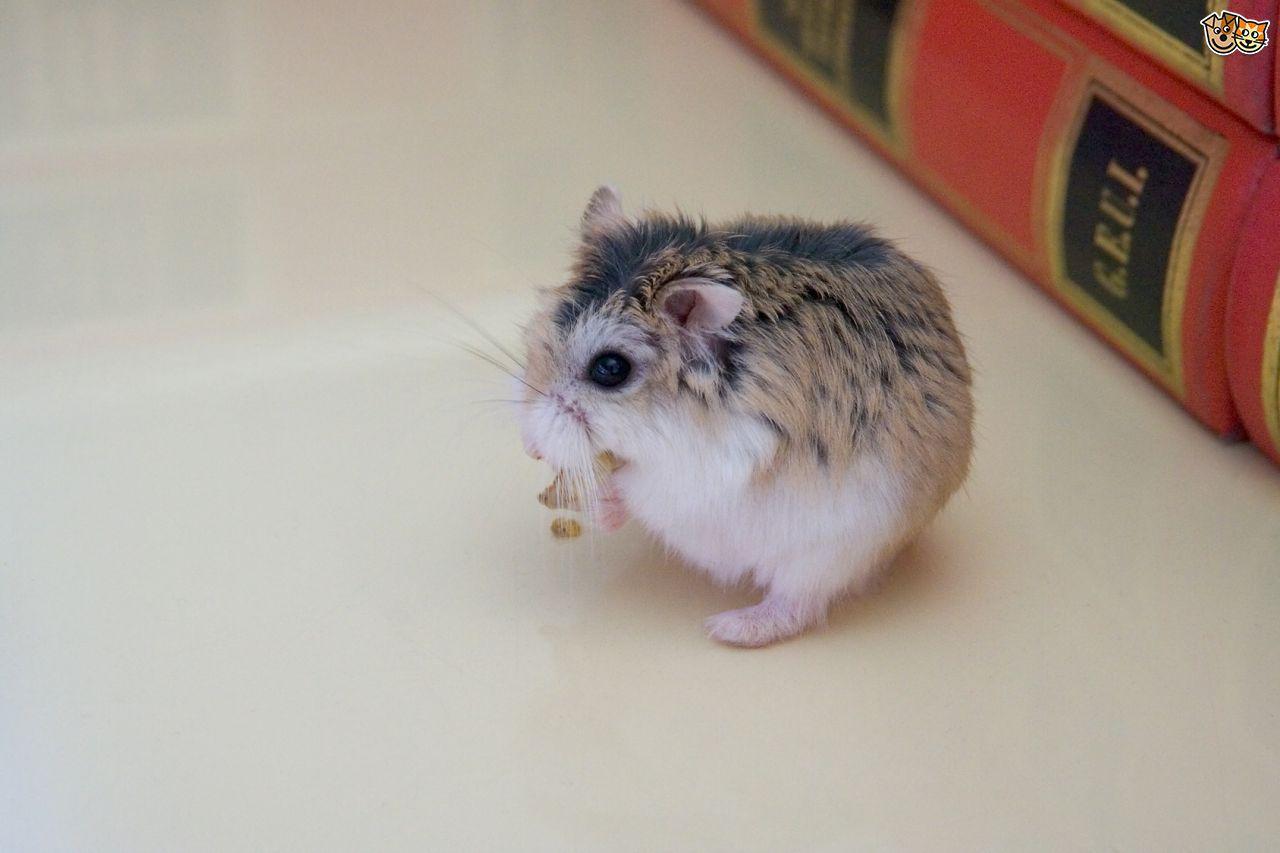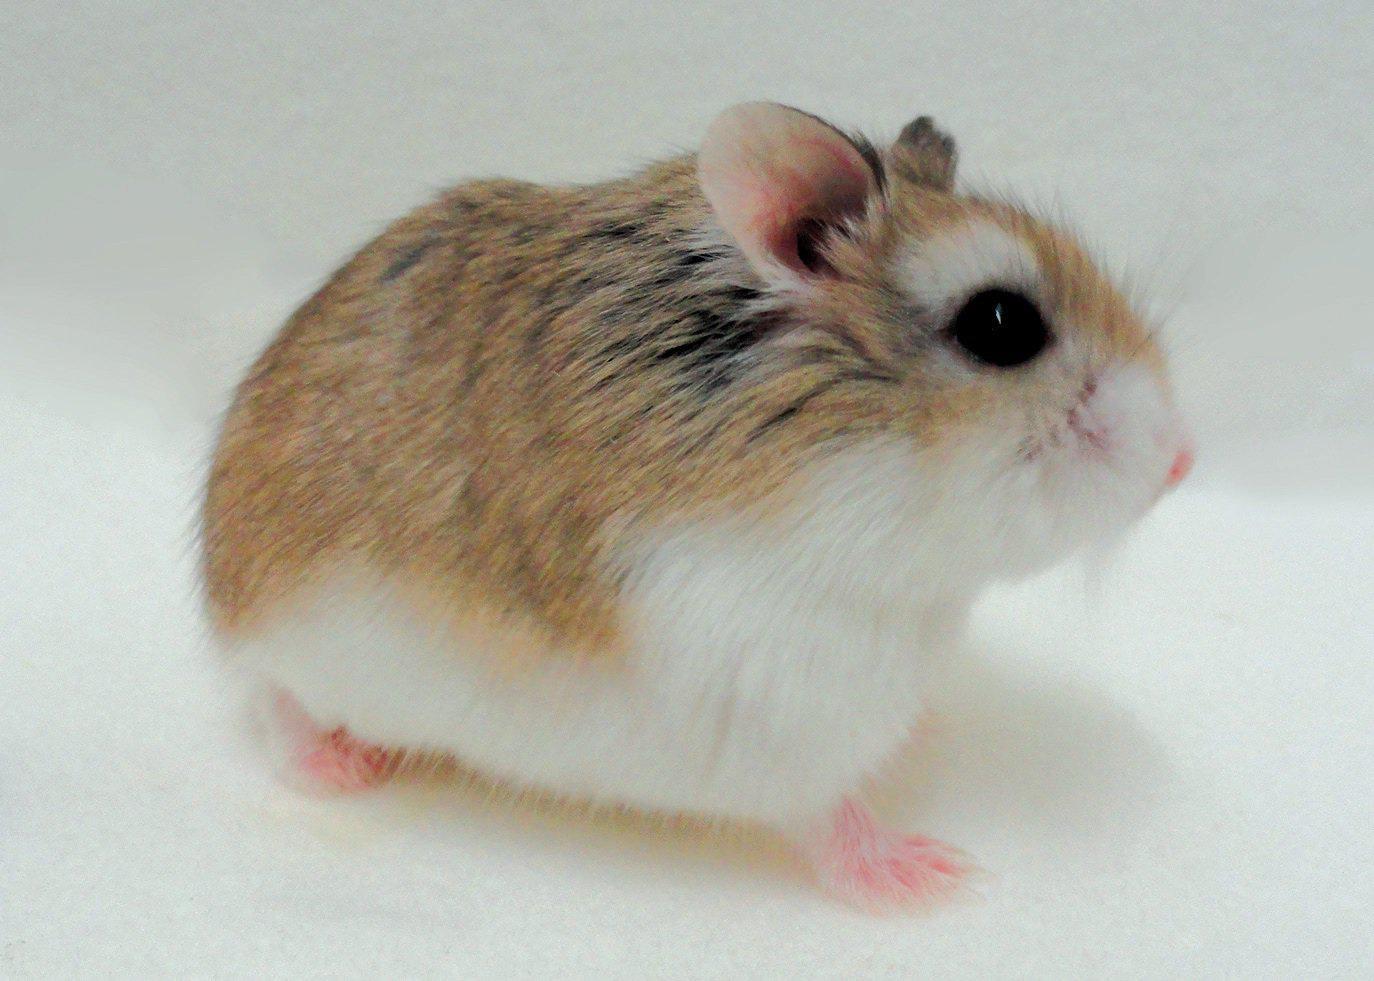The first image is the image on the left, the second image is the image on the right. For the images shown, is this caption "An image shows at least one pet rodent by a piece of bright orange food." true? Answer yes or no. No. The first image is the image on the left, the second image is the image on the right. For the images shown, is this caption "All the rodents are sitting on a white surface." true? Answer yes or no. Yes. 